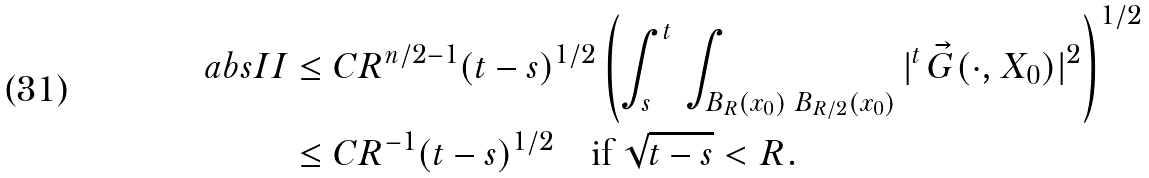<formula> <loc_0><loc_0><loc_500><loc_500>\ a b s { I I } & \leq C R ^ { n / 2 - 1 } ( t - s ) ^ { 1 / 2 } \left ( \int _ { s } ^ { t } \, \int _ { B _ { R } ( x _ { 0 } ) \ B _ { R / 2 } ( x _ { 0 } ) } | ^ { t } \, \vec { G } ( \cdot , X _ { 0 } ) | ^ { 2 } \right ) ^ { 1 / 2 } \\ & \leq C R ^ { - 1 } ( t - s ) ^ { 1 / 2 } \quad \text {if } \sqrt { t - s } < R .</formula> 